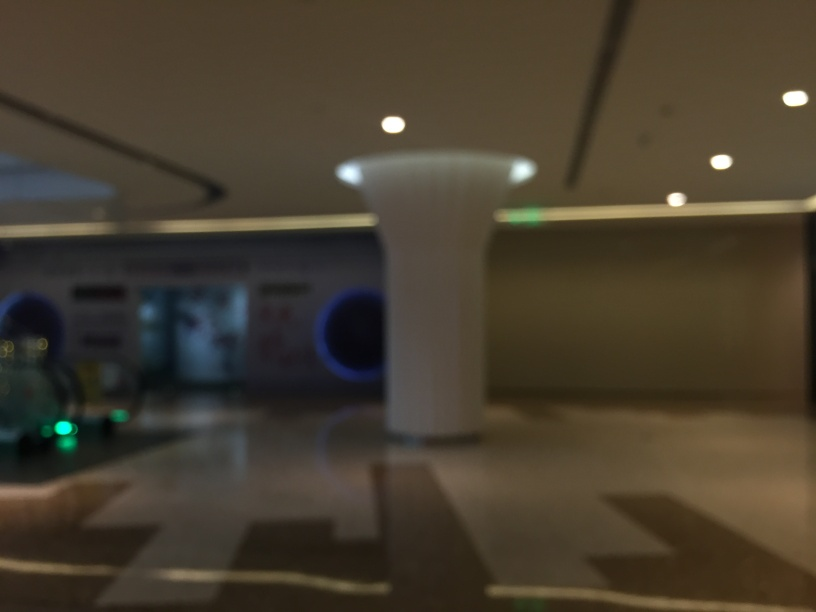What suggestions do you have to improve the photograph? Improving this photograph would involve ensuring the camera is focused properly on the subject to achieve clarity. Additionally, using a tripod or a steady hand to avoid camera shake and adjusting the lighting or using a higher resolution camera may enhance the image quality. 